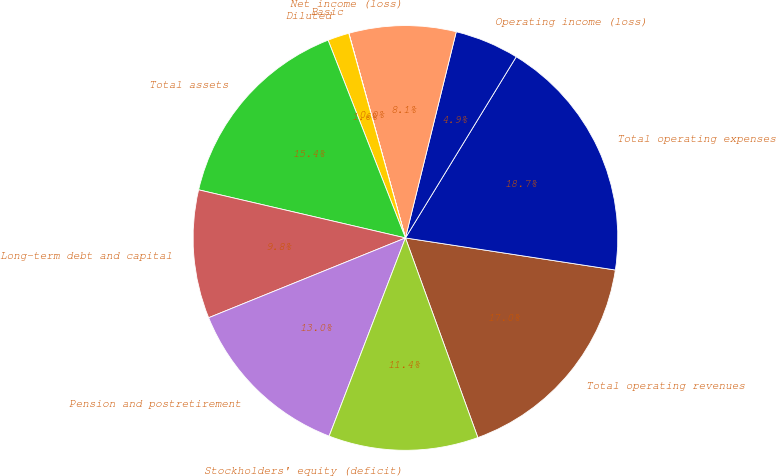Convert chart to OTSL. <chart><loc_0><loc_0><loc_500><loc_500><pie_chart><fcel>Total operating revenues<fcel>Total operating expenses<fcel>Operating income (loss)<fcel>Net income (loss)<fcel>Basic<fcel>Diluted<fcel>Total assets<fcel>Long-term debt and capital<fcel>Pension and postretirement<fcel>Stockholders' equity (deficit)<nl><fcel>17.05%<fcel>18.68%<fcel>4.89%<fcel>8.14%<fcel>0.01%<fcel>1.63%<fcel>15.43%<fcel>9.77%<fcel>13.02%<fcel>11.39%<nl></chart> 